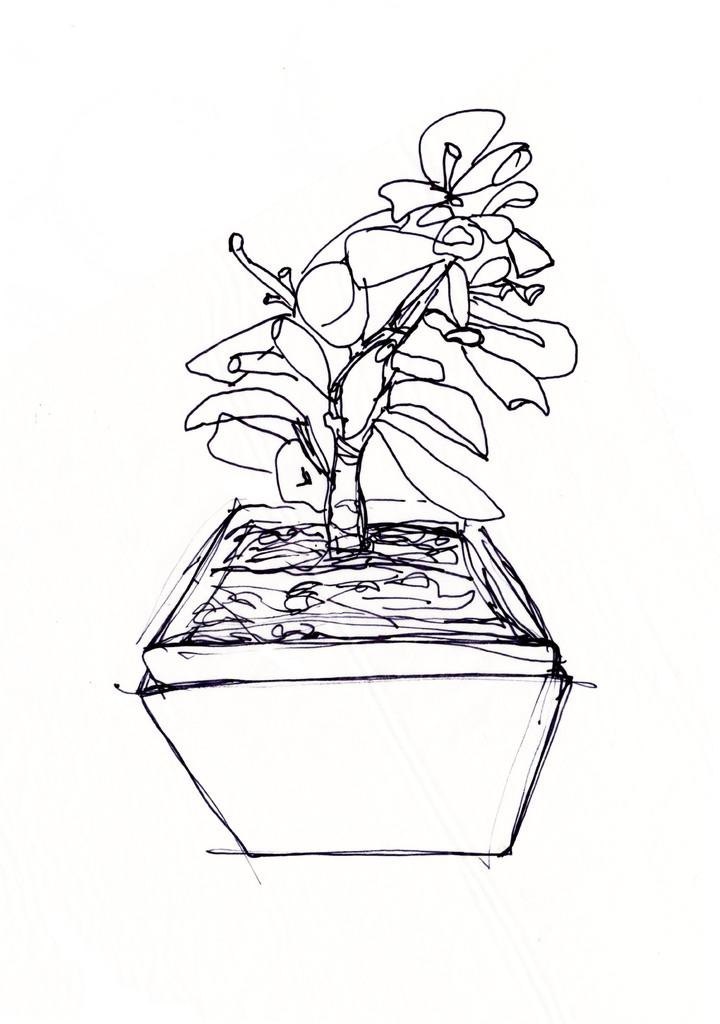What is depicted in the image? There is an art of a flower pot in the image. What color is the background of the image? The background of the image is white. How many flowers are in the room in the image? There is no room or flowers present in the image; it features an art of a flower pot with a white background. 